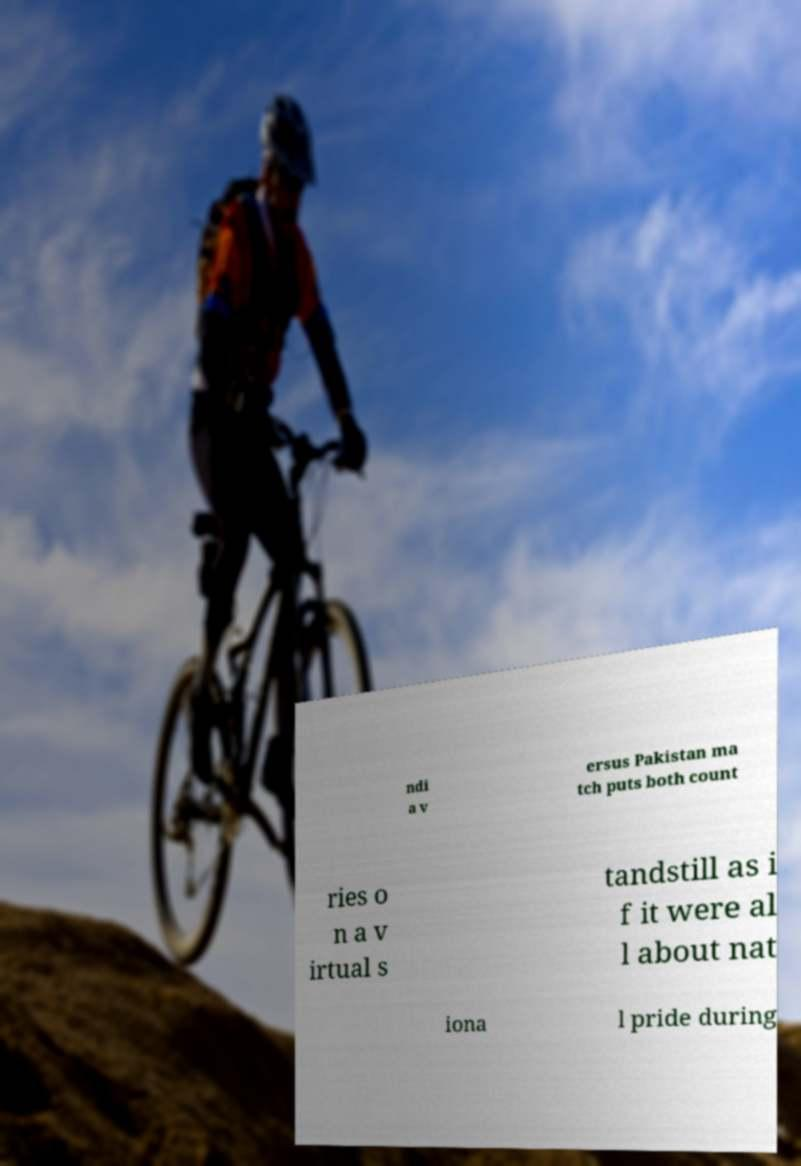For documentation purposes, I need the text within this image transcribed. Could you provide that? ndi a v ersus Pakistan ma tch puts both count ries o n a v irtual s tandstill as i f it were al l about nat iona l pride during 